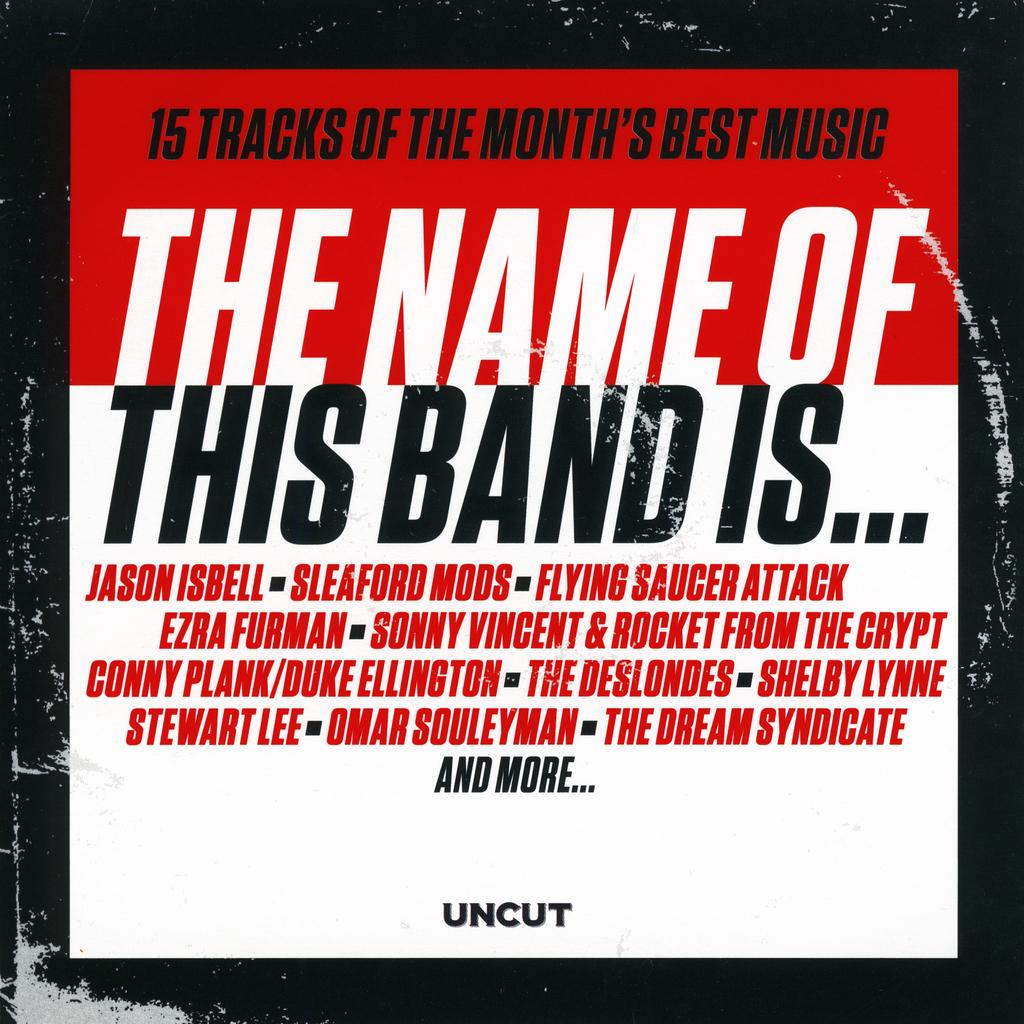Provide a one-sentence caption for the provided image. AN ALBUM COVER INTITLED THE NAME OF THIS BAND IS ... 